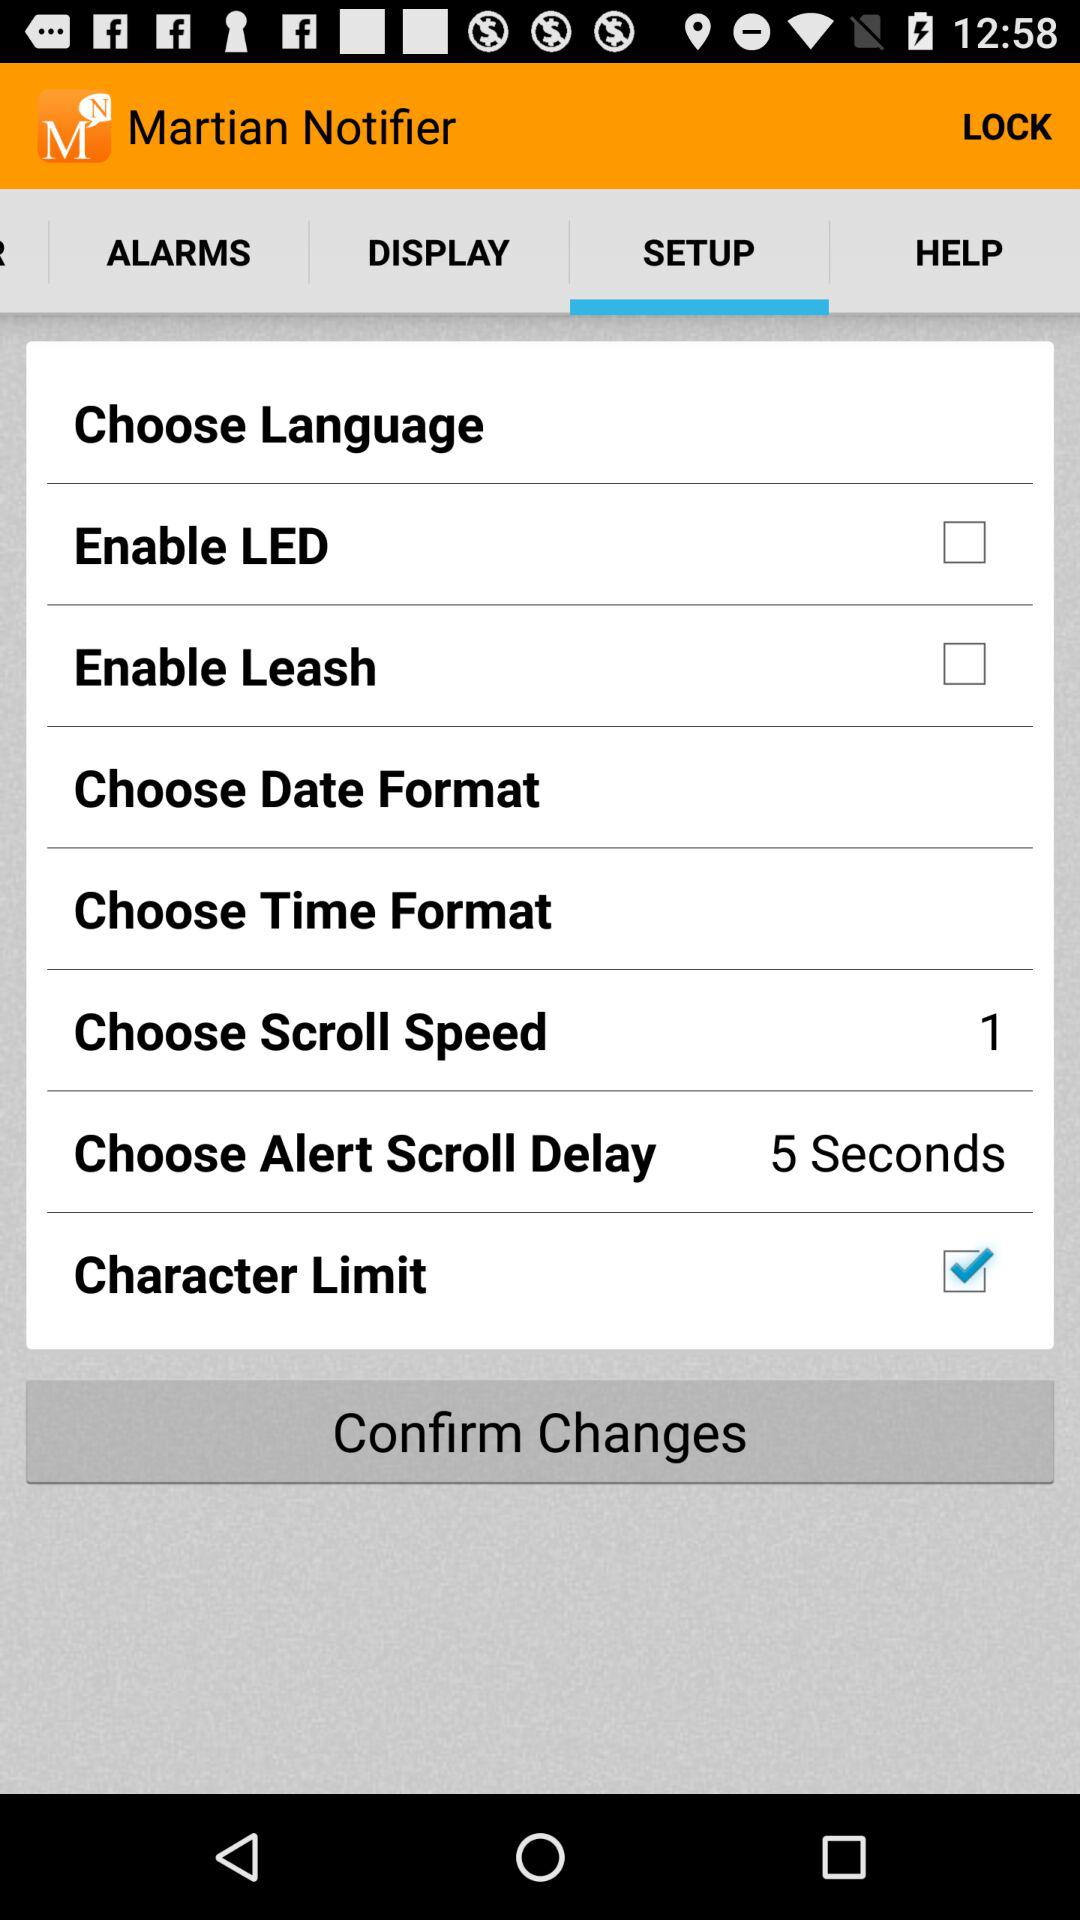Which option is checked? The checked option is "Character Limit". 